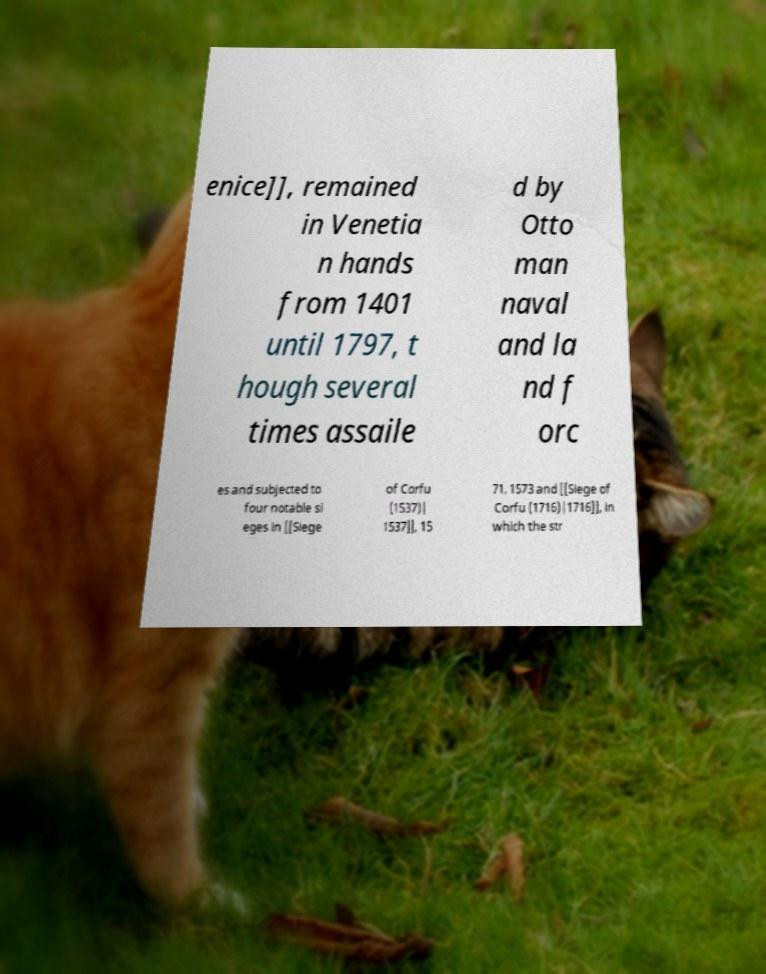Can you accurately transcribe the text from the provided image for me? enice]], remained in Venetia n hands from 1401 until 1797, t hough several times assaile d by Otto man naval and la nd f orc es and subjected to four notable si eges in [[Siege of Corfu (1537)| 1537]], 15 71, 1573 and [[Siege of Corfu (1716)|1716]], in which the str 